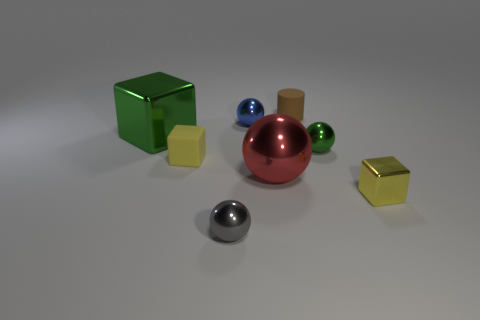Add 1 large brown metallic balls. How many objects exist? 9 Subtract all small spheres. How many spheres are left? 1 Subtract all blue blocks. How many gray balls are left? 1 Subtract all large gray metal blocks. Subtract all tiny objects. How many objects are left? 2 Add 2 blue metal things. How many blue metal things are left? 3 Add 5 blue objects. How many blue objects exist? 6 Subtract all green blocks. How many blocks are left? 2 Subtract 1 green blocks. How many objects are left? 7 Subtract all cylinders. How many objects are left? 7 Subtract 1 balls. How many balls are left? 3 